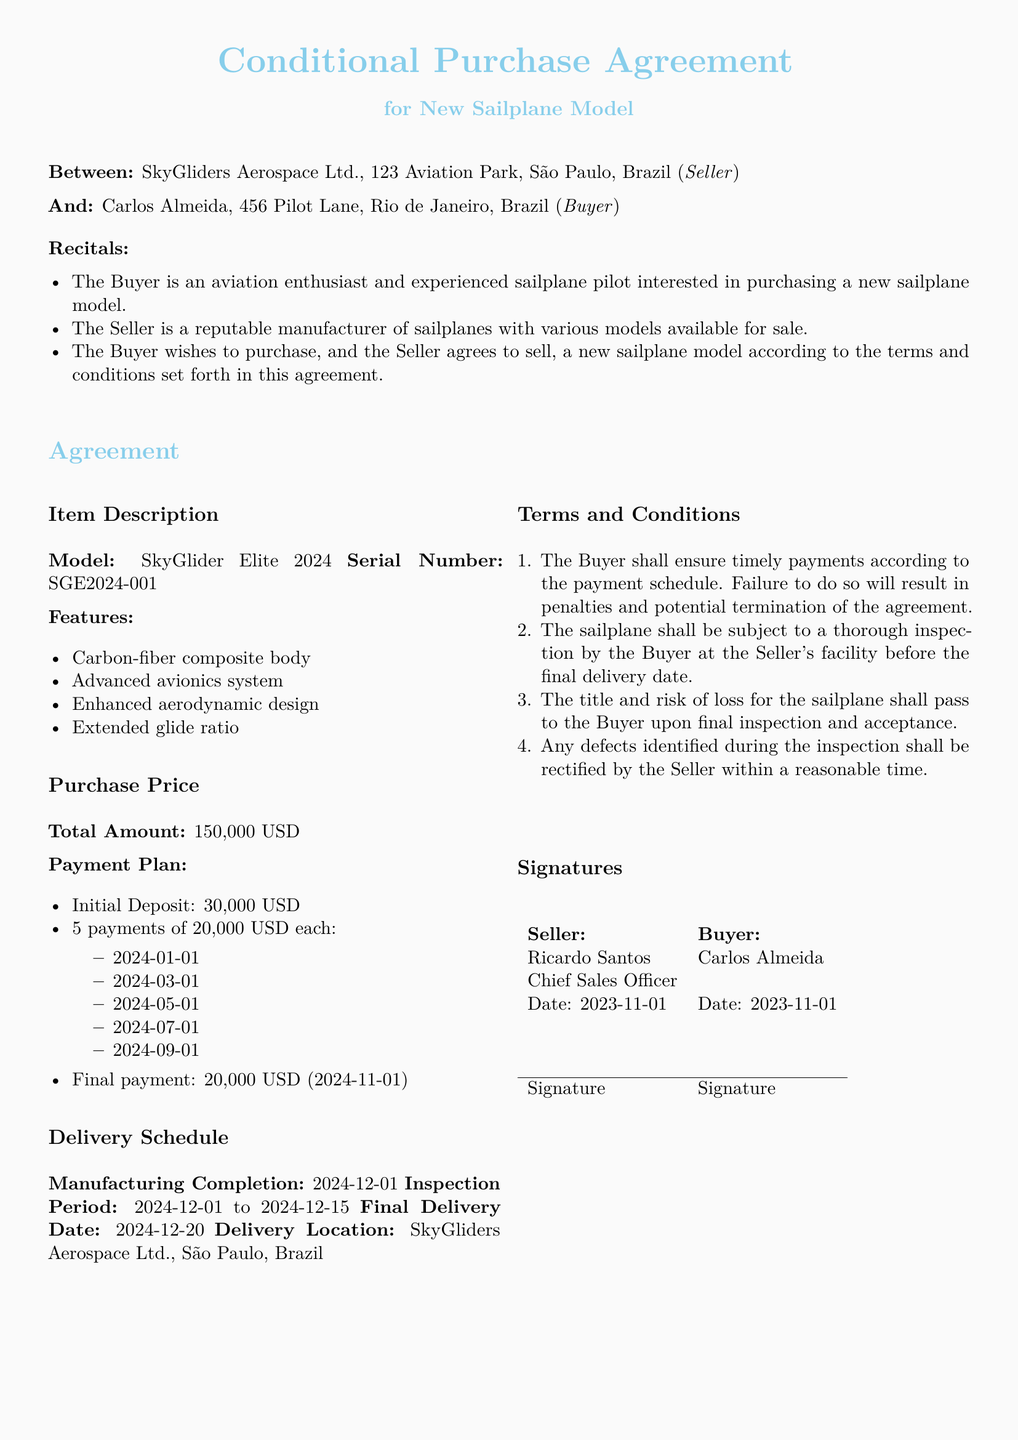What is the model of the sailplane? The model of the sailplane is stated in the document as "SkyGlider Elite 2024."
Answer: SkyGlider Elite 2024 Who is the seller? The seller is identified in the document as "SkyGliders Aerospace Ltd."
Answer: SkyGliders Aerospace Ltd What is the initial deposit amount? The initial deposit amount is specified in the payment plan section as 30,000 USD.
Answer: 30,000 USD What is the final delivery date? The final delivery date is outlined as 2024-12-20 in the delivery schedule.
Answer: 2024-12-20 How many payments are scheduled in the payment plan? The payment plan indicates there are six scheduled payments in total.
Answer: Six What happens if the buyer fails to make timely payments? The document states that failure to make timely payments may result in penalties and potential termination of the agreement.
Answer: Penalties and potential termination When does the inspection period occur? The inspection period is mentioned to be from 2024-12-01 to 2024-12-15.
Answer: 2024-12-01 to 2024-12-15 Who has to ensure timely payments according to the agreement? The agreement specifies that the buyer is responsible for ensuring timely payments.
Answer: The buyer What is the total purchase price of the sailplane? The total purchase price is explicitly listed as 150,000 USD.
Answer: 150,000 USD 